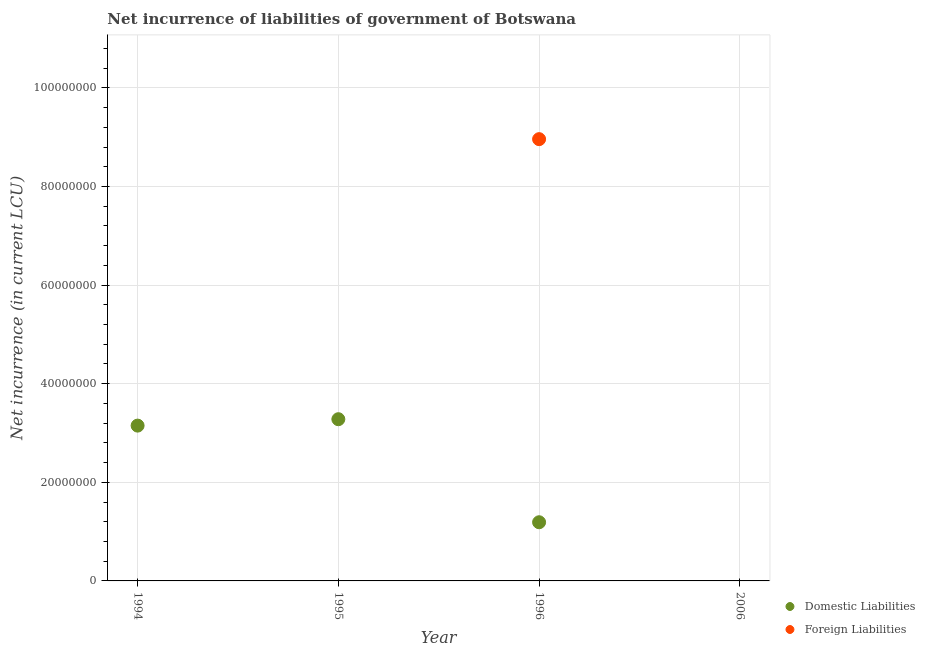How many different coloured dotlines are there?
Make the answer very short. 2. Is the number of dotlines equal to the number of legend labels?
Your answer should be compact. No. What is the net incurrence of foreign liabilities in 2006?
Your answer should be compact. 0. Across all years, what is the maximum net incurrence of domestic liabilities?
Your answer should be very brief. 3.28e+07. Across all years, what is the minimum net incurrence of domestic liabilities?
Keep it short and to the point. 0. What is the total net incurrence of domestic liabilities in the graph?
Keep it short and to the point. 7.62e+07. What is the difference between the net incurrence of domestic liabilities in 1995 and that in 1996?
Provide a succinct answer. 2.09e+07. What is the difference between the net incurrence of domestic liabilities in 1994 and the net incurrence of foreign liabilities in 2006?
Make the answer very short. 3.15e+07. What is the average net incurrence of foreign liabilities per year?
Keep it short and to the point. 2.24e+07. In the year 1996, what is the difference between the net incurrence of foreign liabilities and net incurrence of domestic liabilities?
Give a very brief answer. 7.77e+07. What is the ratio of the net incurrence of domestic liabilities in 1995 to that in 1996?
Offer a terse response. 2.76. What is the difference between the highest and the second highest net incurrence of domestic liabilities?
Ensure brevity in your answer.  1.30e+06. What is the difference between the highest and the lowest net incurrence of domestic liabilities?
Make the answer very short. 3.28e+07. In how many years, is the net incurrence of foreign liabilities greater than the average net incurrence of foreign liabilities taken over all years?
Your response must be concise. 1. Does the net incurrence of foreign liabilities monotonically increase over the years?
Your response must be concise. No. Is the net incurrence of domestic liabilities strictly greater than the net incurrence of foreign liabilities over the years?
Offer a very short reply. No. How many years are there in the graph?
Ensure brevity in your answer.  4. Are the values on the major ticks of Y-axis written in scientific E-notation?
Provide a succinct answer. No. Where does the legend appear in the graph?
Ensure brevity in your answer.  Bottom right. How many legend labels are there?
Ensure brevity in your answer.  2. What is the title of the graph?
Provide a succinct answer. Net incurrence of liabilities of government of Botswana. What is the label or title of the Y-axis?
Keep it short and to the point. Net incurrence (in current LCU). What is the Net incurrence (in current LCU) of Domestic Liabilities in 1994?
Your answer should be compact. 3.15e+07. What is the Net incurrence (in current LCU) in Foreign Liabilities in 1994?
Your response must be concise. 0. What is the Net incurrence (in current LCU) of Domestic Liabilities in 1995?
Ensure brevity in your answer.  3.28e+07. What is the Net incurrence (in current LCU) of Foreign Liabilities in 1995?
Provide a short and direct response. 0. What is the Net incurrence (in current LCU) in Domestic Liabilities in 1996?
Offer a terse response. 1.19e+07. What is the Net incurrence (in current LCU) in Foreign Liabilities in 1996?
Ensure brevity in your answer.  8.96e+07. What is the Net incurrence (in current LCU) in Domestic Liabilities in 2006?
Your answer should be very brief. 0. Across all years, what is the maximum Net incurrence (in current LCU) in Domestic Liabilities?
Offer a terse response. 3.28e+07. Across all years, what is the maximum Net incurrence (in current LCU) of Foreign Liabilities?
Your response must be concise. 8.96e+07. Across all years, what is the minimum Net incurrence (in current LCU) in Domestic Liabilities?
Your answer should be very brief. 0. Across all years, what is the minimum Net incurrence (in current LCU) of Foreign Liabilities?
Keep it short and to the point. 0. What is the total Net incurrence (in current LCU) in Domestic Liabilities in the graph?
Offer a very short reply. 7.62e+07. What is the total Net incurrence (in current LCU) of Foreign Liabilities in the graph?
Your answer should be very brief. 8.96e+07. What is the difference between the Net incurrence (in current LCU) in Domestic Liabilities in 1994 and that in 1995?
Offer a very short reply. -1.30e+06. What is the difference between the Net incurrence (in current LCU) of Domestic Liabilities in 1994 and that in 1996?
Keep it short and to the point. 1.96e+07. What is the difference between the Net incurrence (in current LCU) in Domestic Liabilities in 1995 and that in 1996?
Give a very brief answer. 2.09e+07. What is the difference between the Net incurrence (in current LCU) in Domestic Liabilities in 1994 and the Net incurrence (in current LCU) in Foreign Liabilities in 1996?
Give a very brief answer. -5.81e+07. What is the difference between the Net incurrence (in current LCU) in Domestic Liabilities in 1995 and the Net incurrence (in current LCU) in Foreign Liabilities in 1996?
Provide a succinct answer. -5.68e+07. What is the average Net incurrence (in current LCU) of Domestic Liabilities per year?
Ensure brevity in your answer.  1.90e+07. What is the average Net incurrence (in current LCU) of Foreign Liabilities per year?
Keep it short and to the point. 2.24e+07. In the year 1996, what is the difference between the Net incurrence (in current LCU) of Domestic Liabilities and Net incurrence (in current LCU) of Foreign Liabilities?
Ensure brevity in your answer.  -7.77e+07. What is the ratio of the Net incurrence (in current LCU) of Domestic Liabilities in 1994 to that in 1995?
Offer a very short reply. 0.96. What is the ratio of the Net incurrence (in current LCU) in Domestic Liabilities in 1994 to that in 1996?
Your response must be concise. 2.65. What is the ratio of the Net incurrence (in current LCU) in Domestic Liabilities in 1995 to that in 1996?
Your answer should be very brief. 2.76. What is the difference between the highest and the second highest Net incurrence (in current LCU) of Domestic Liabilities?
Your response must be concise. 1.30e+06. What is the difference between the highest and the lowest Net incurrence (in current LCU) of Domestic Liabilities?
Make the answer very short. 3.28e+07. What is the difference between the highest and the lowest Net incurrence (in current LCU) in Foreign Liabilities?
Offer a terse response. 8.96e+07. 